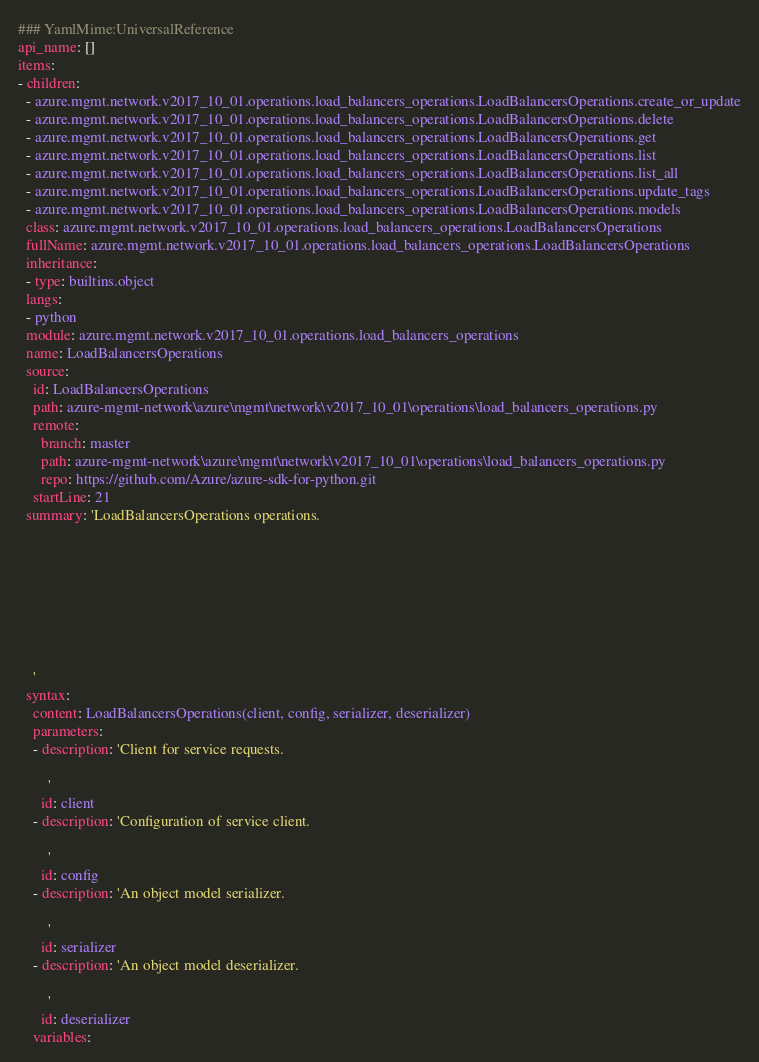Convert code to text. <code><loc_0><loc_0><loc_500><loc_500><_YAML_>### YamlMime:UniversalReference
api_name: []
items:
- children:
  - azure.mgmt.network.v2017_10_01.operations.load_balancers_operations.LoadBalancersOperations.create_or_update
  - azure.mgmt.network.v2017_10_01.operations.load_balancers_operations.LoadBalancersOperations.delete
  - azure.mgmt.network.v2017_10_01.operations.load_balancers_operations.LoadBalancersOperations.get
  - azure.mgmt.network.v2017_10_01.operations.load_balancers_operations.LoadBalancersOperations.list
  - azure.mgmt.network.v2017_10_01.operations.load_balancers_operations.LoadBalancersOperations.list_all
  - azure.mgmt.network.v2017_10_01.operations.load_balancers_operations.LoadBalancersOperations.update_tags
  - azure.mgmt.network.v2017_10_01.operations.load_balancers_operations.LoadBalancersOperations.models
  class: azure.mgmt.network.v2017_10_01.operations.load_balancers_operations.LoadBalancersOperations
  fullName: azure.mgmt.network.v2017_10_01.operations.load_balancers_operations.LoadBalancersOperations
  inheritance:
  - type: builtins.object
  langs:
  - python
  module: azure.mgmt.network.v2017_10_01.operations.load_balancers_operations
  name: LoadBalancersOperations
  source:
    id: LoadBalancersOperations
    path: azure-mgmt-network\azure\mgmt\network\v2017_10_01\operations\load_balancers_operations.py
    remote:
      branch: master
      path: azure-mgmt-network\azure\mgmt\network\v2017_10_01\operations\load_balancers_operations.py
      repo: https://github.com/Azure/azure-sdk-for-python.git
    startLine: 21
  summary: 'LoadBalancersOperations operations.








    '
  syntax:
    content: LoadBalancersOperations(client, config, serializer, deserializer)
    parameters:
    - description: 'Client for service requests.

        '
      id: client
    - description: 'Configuration of service client.

        '
      id: config
    - description: 'An object model serializer.

        '
      id: serializer
    - description: 'An object model deserializer.

        '
      id: deserializer
    variables:</code> 